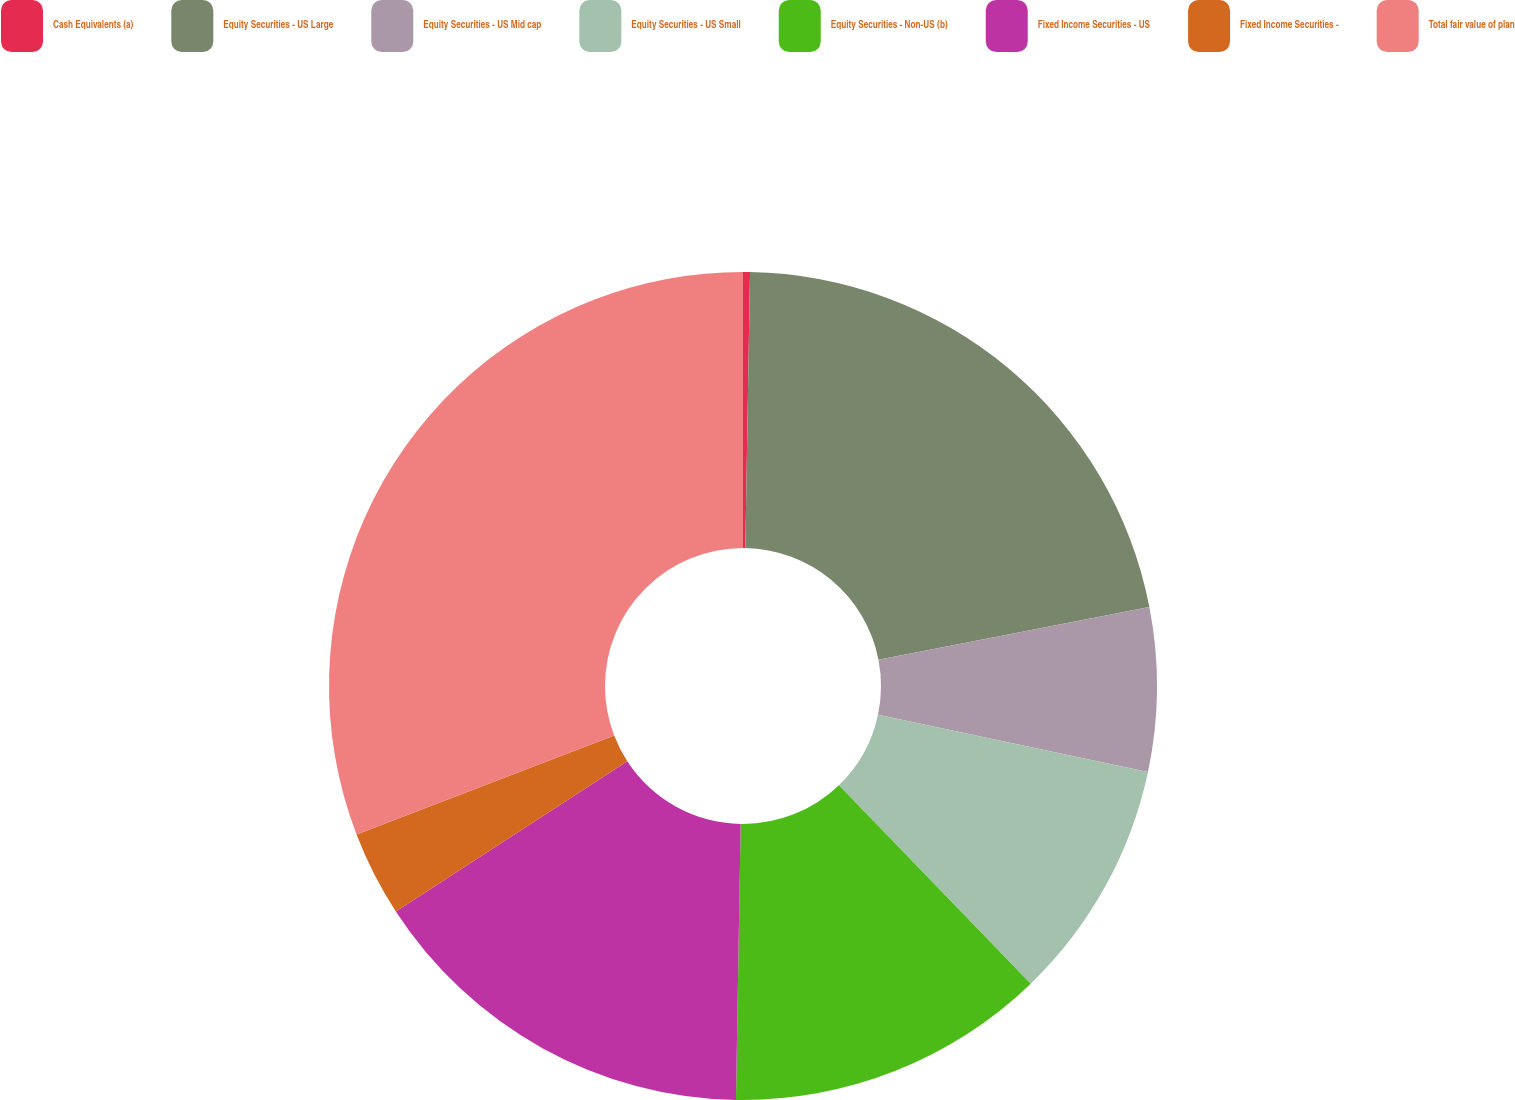Convert chart to OTSL. <chart><loc_0><loc_0><loc_500><loc_500><pie_chart><fcel>Cash Equivalents (a)<fcel>Equity Securities - US Large<fcel>Equity Securities - US Mid cap<fcel>Equity Securities - US Small<fcel>Equity Securities - Non-US (b)<fcel>Fixed Income Securities - US<fcel>Fixed Income Securities -<fcel>Total fair value of plan<nl><fcel>0.27%<fcel>21.67%<fcel>6.39%<fcel>9.44%<fcel>12.5%<fcel>15.56%<fcel>3.33%<fcel>30.84%<nl></chart> 